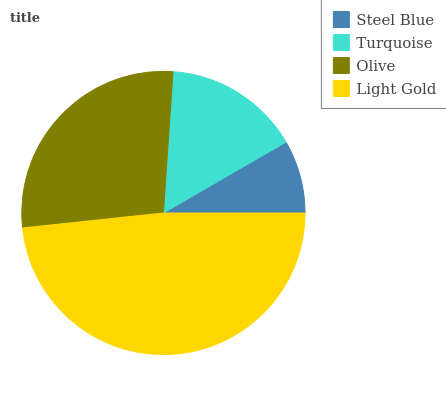Is Steel Blue the minimum?
Answer yes or no. Yes. Is Light Gold the maximum?
Answer yes or no. Yes. Is Turquoise the minimum?
Answer yes or no. No. Is Turquoise the maximum?
Answer yes or no. No. Is Turquoise greater than Steel Blue?
Answer yes or no. Yes. Is Steel Blue less than Turquoise?
Answer yes or no. Yes. Is Steel Blue greater than Turquoise?
Answer yes or no. No. Is Turquoise less than Steel Blue?
Answer yes or no. No. Is Olive the high median?
Answer yes or no. Yes. Is Turquoise the low median?
Answer yes or no. Yes. Is Turquoise the high median?
Answer yes or no. No. Is Light Gold the low median?
Answer yes or no. No. 